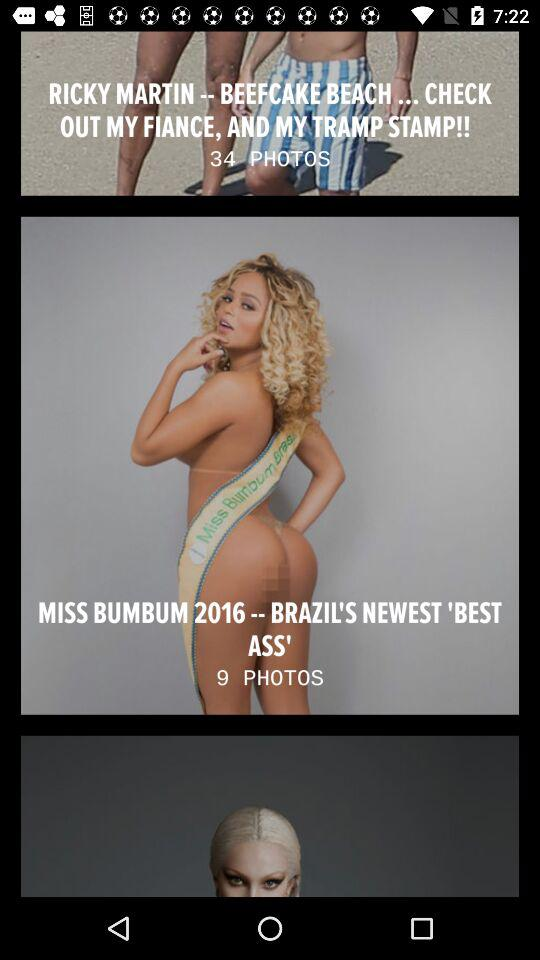How many total photos are there of "MISS BUMBUM 2016"? There are 9 photos. 